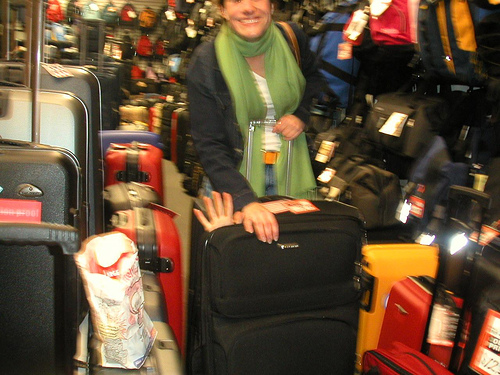How many backpacks are in the picture? There is actually only one backpack visible on the left side of the image, amidst an assortment of luggage pieces. The other items in the photo include a variety of suitcases and travel bags, but just a single backpack. 